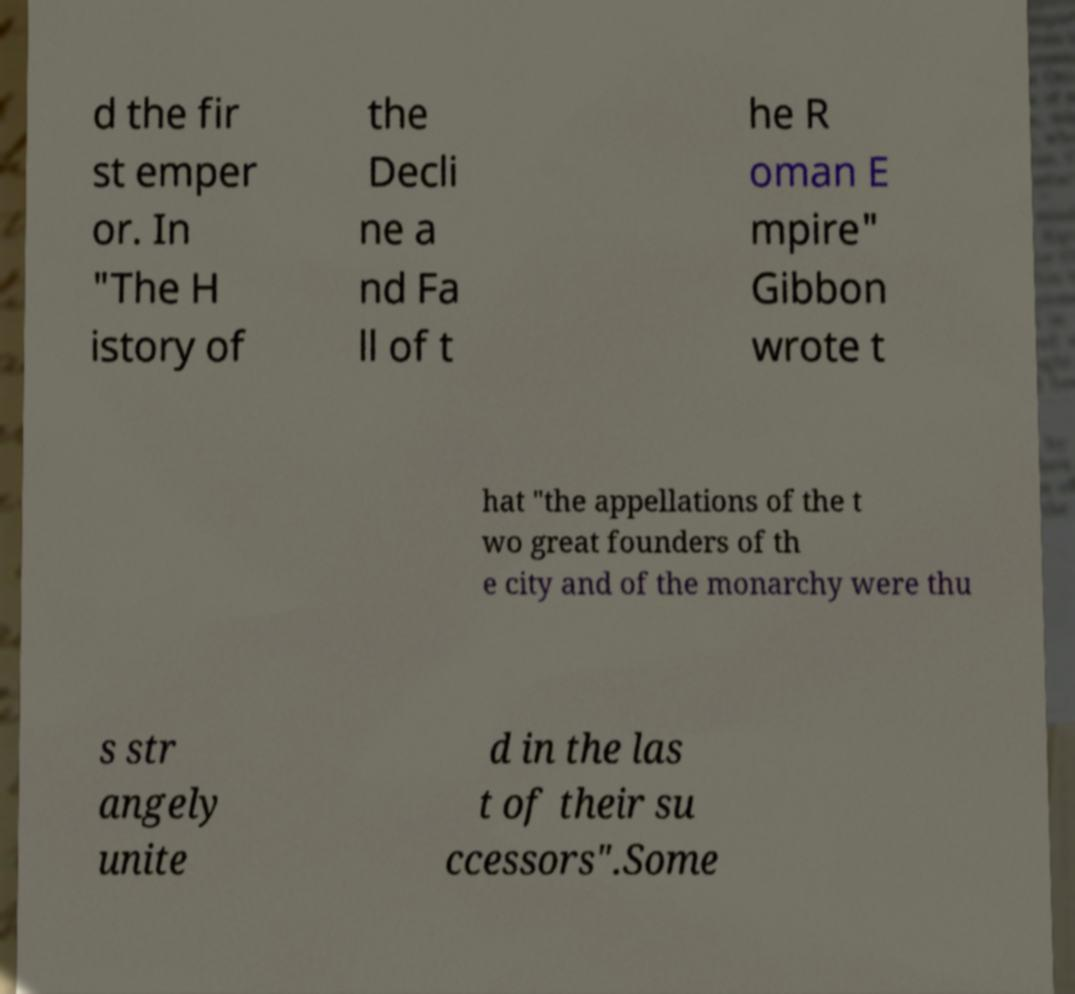For documentation purposes, I need the text within this image transcribed. Could you provide that? d the fir st emper or. In "The H istory of the Decli ne a nd Fa ll of t he R oman E mpire" Gibbon wrote t hat "the appellations of the t wo great founders of th e city and of the monarchy were thu s str angely unite d in the las t of their su ccessors".Some 